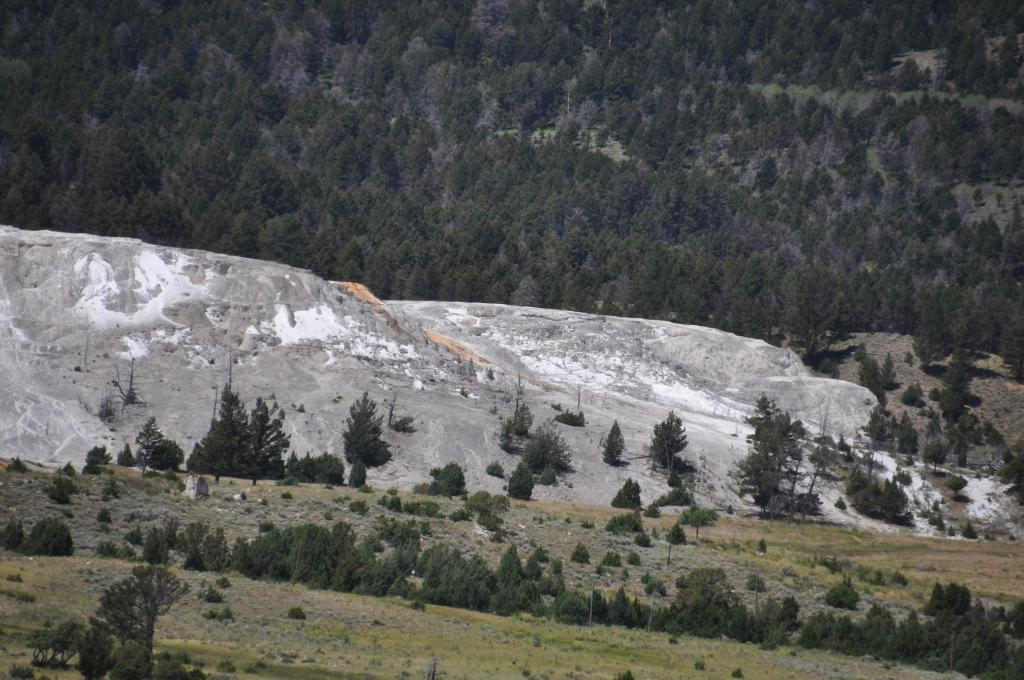What type of terrain is visible in the image? There is ground visible in the image. What type of vegetation can be seen in the image? There are plants and trees in the image. What geographical feature is present in the image? There is a mountain in the image. What is the secretary doing on the mountain in the image? There is no secretary present in the image, and the mountain is not depicted as having any human activity. 